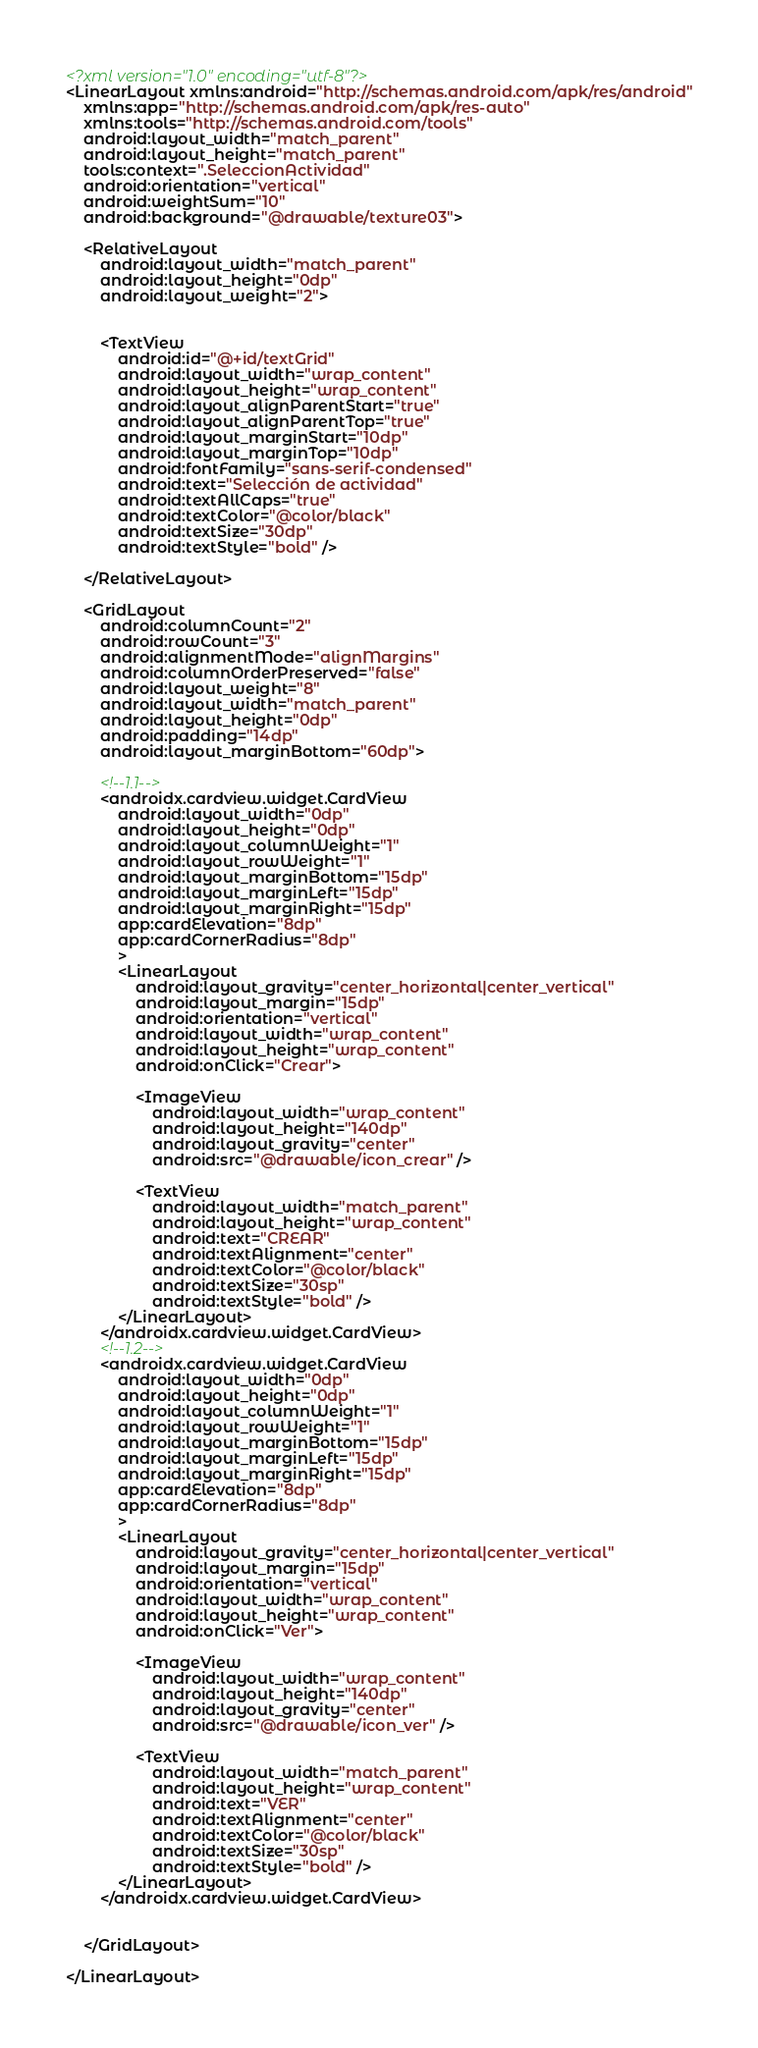<code> <loc_0><loc_0><loc_500><loc_500><_XML_><?xml version="1.0" encoding="utf-8"?>
<LinearLayout xmlns:android="http://schemas.android.com/apk/res/android"
    xmlns:app="http://schemas.android.com/apk/res-auto"
    xmlns:tools="http://schemas.android.com/tools"
    android:layout_width="match_parent"
    android:layout_height="match_parent"
    tools:context=".SeleccionActividad"
    android:orientation="vertical"
    android:weightSum="10"
    android:background="@drawable/texture03">

    <RelativeLayout
        android:layout_width="match_parent"
        android:layout_height="0dp"
        android:layout_weight="2">


        <TextView
            android:id="@+id/textGrid"
            android:layout_width="wrap_content"
            android:layout_height="wrap_content"
            android:layout_alignParentStart="true"
            android:layout_alignParentTop="true"
            android:layout_marginStart="10dp"
            android:layout_marginTop="10dp"
            android:fontFamily="sans-serif-condensed"
            android:text="Selección de actividad"
            android:textAllCaps="true"
            android:textColor="@color/black"
            android:textSize="30dp"
            android:textStyle="bold" />

    </RelativeLayout>

    <GridLayout
        android:columnCount="2"
        android:rowCount="3"
        android:alignmentMode="alignMargins"
        android:columnOrderPreserved="false"
        android:layout_weight="8"
        android:layout_width="match_parent"
        android:layout_height="0dp"
        android:padding="14dp"
        android:layout_marginBottom="60dp">

        <!--1.1-->
        <androidx.cardview.widget.CardView
            android:layout_width="0dp"
            android:layout_height="0dp"
            android:layout_columnWeight="1"
            android:layout_rowWeight="1"
            android:layout_marginBottom="15dp"
            android:layout_marginLeft="15dp"
            android:layout_marginRight="15dp"
            app:cardElevation="8dp"
            app:cardCornerRadius="8dp"
            >
            <LinearLayout
                android:layout_gravity="center_horizontal|center_vertical"
                android:layout_margin="15dp"
                android:orientation="vertical"
                android:layout_width="wrap_content"
                android:layout_height="wrap_content"
                android:onClick="Crear">

                <ImageView
                    android:layout_width="wrap_content"
                    android:layout_height="140dp"
                    android:layout_gravity="center"
                    android:src="@drawable/icon_crear" />

                <TextView
                    android:layout_width="match_parent"
                    android:layout_height="wrap_content"
                    android:text="CREAR"
                    android:textAlignment="center"
                    android:textColor="@color/black"
                    android:textSize="30sp"
                    android:textStyle="bold" />
            </LinearLayout>
        </androidx.cardview.widget.CardView>
        <!--1.2-->
        <androidx.cardview.widget.CardView
            android:layout_width="0dp"
            android:layout_height="0dp"
            android:layout_columnWeight="1"
            android:layout_rowWeight="1"
            android:layout_marginBottom="15dp"
            android:layout_marginLeft="15dp"
            android:layout_marginRight="15dp"
            app:cardElevation="8dp"
            app:cardCornerRadius="8dp"
            >
            <LinearLayout
                android:layout_gravity="center_horizontal|center_vertical"
                android:layout_margin="15dp"
                android:orientation="vertical"
                android:layout_width="wrap_content"
                android:layout_height="wrap_content"
                android:onClick="Ver">

                <ImageView
                    android:layout_width="wrap_content"
                    android:layout_height="140dp"
                    android:layout_gravity="center"
                    android:src="@drawable/icon_ver" />

                <TextView
                    android:layout_width="match_parent"
                    android:layout_height="wrap_content"
                    android:text="VER"
                    android:textAlignment="center"
                    android:textColor="@color/black"
                    android:textSize="30sp"
                    android:textStyle="bold" />
            </LinearLayout>
        </androidx.cardview.widget.CardView>


    </GridLayout>

</LinearLayout>


</code> 